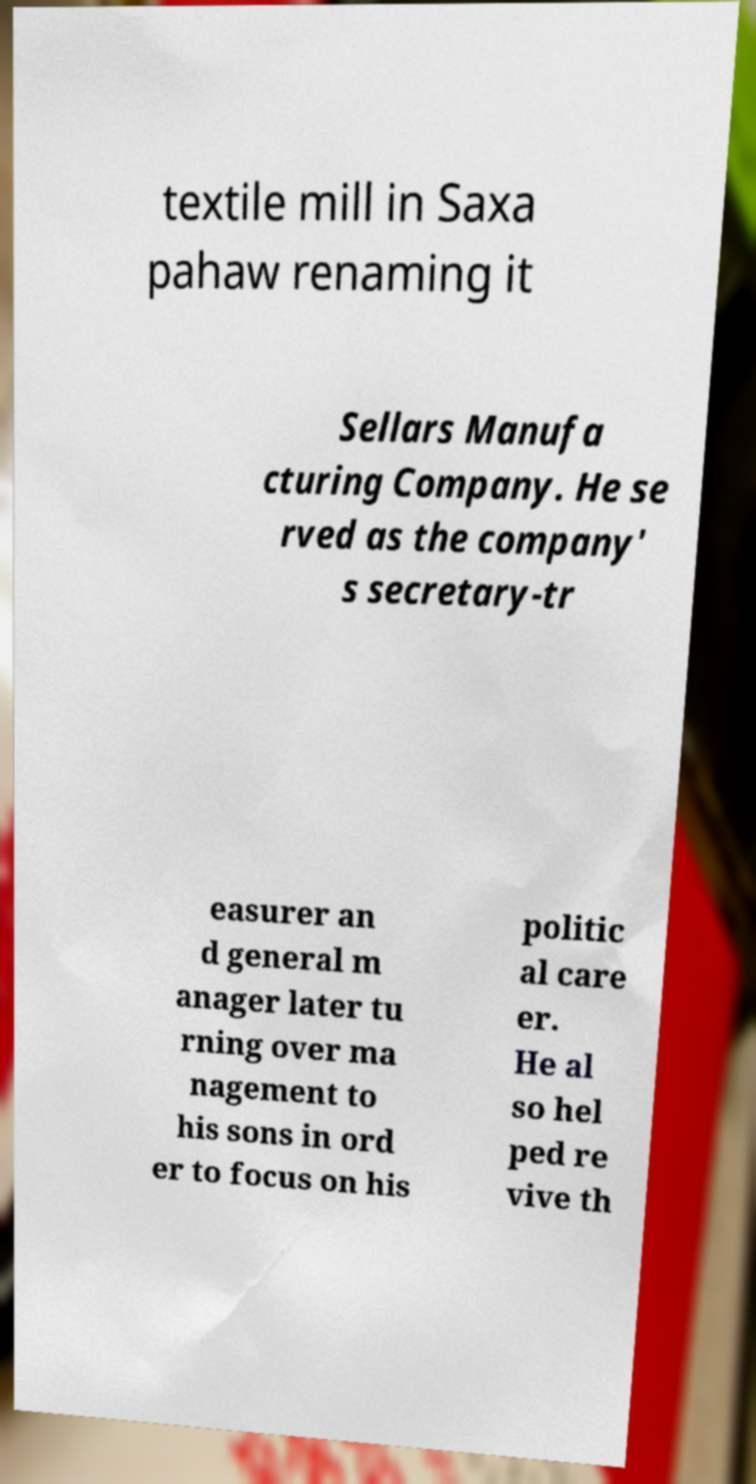There's text embedded in this image that I need extracted. Can you transcribe it verbatim? textile mill in Saxa pahaw renaming it Sellars Manufa cturing Company. He se rved as the company' s secretary-tr easurer an d general m anager later tu rning over ma nagement to his sons in ord er to focus on his politic al care er. He al so hel ped re vive th 